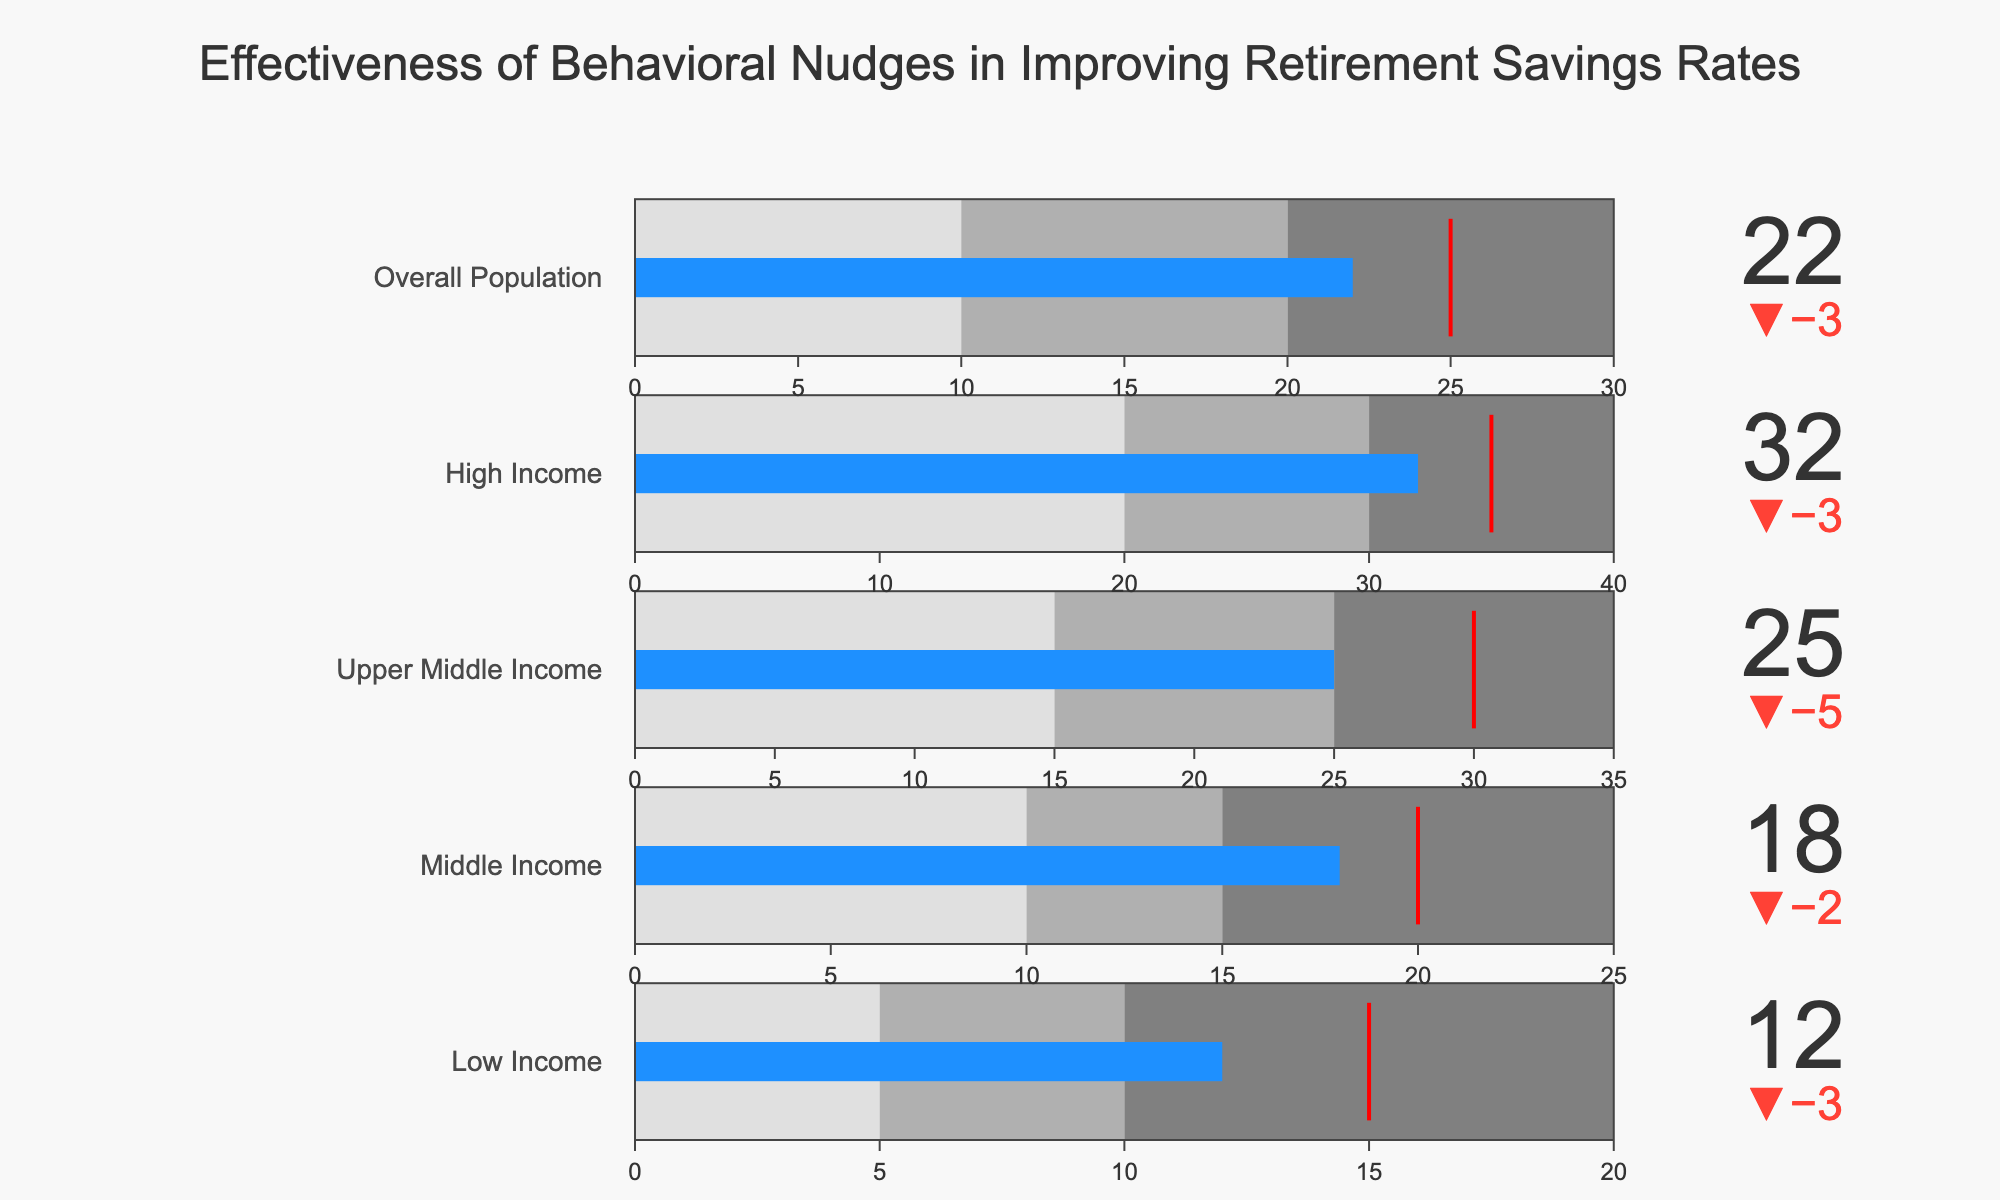What is the actual retirement savings rate for the "Middle Income" category? The "Middle Income" category has a bullet indicator, and the actual value is displayed as 18.
Answer: 18 How does the actual retirement savings rate compare to the target for the "Low Income" category? The "Low Income" category has an actual value of 12, and the target is 15, so the actual value is 3 less than the target.
Answer: 3 less Which income category has achieved the highest actual retirement savings rate? By looking at all the actual values, the "High Income" category has the highest actual rate at 32.
Answer: High Income Is the overall population's actual savings rate above or below the target? The actual value for the overall population is 22, and the target is 25, so it is below the target.
Answer: Below What is the range of the bullet gauge for the "Upper Middle Income" category? The gauge ranges from 0 to its high threshold which is 35 for the "Upper Middle Income" category.
Answer: 0 to 35 How much higher is the actual retirement savings rate for the "High Income" category compared to the "Low Income" category? Subtract the actual rate of "Low Income" (12) from "High Income" (32): 32 - 12 = 20.
Answer: 20 What is the difference between the target and actual savings rates for the "Overall Population"? The target is 25 and the actual is 22, so the difference is 25 - 22 = 3.
Answer: 3 Which income category has the smallest gap between the actual and target savings rates? By examining the deltas for each category, the "Middle Income" category has the smallest gap at 2.
Answer: Middle Income Did any of the categories exceed their high threshold value? None of the actual values exceed their respective high thresholds; all actual values are within their gauge ranges.
Answer: No What general pattern can be observed about the effectiveness of behavioral nudges across different income levels? Higher income categories tend to have higher actual savings rates, but they all still fall short of their target values, indicating that while nudges are effective, they are not completely bridging the gap to the targets.
Answer: Higher income, falls short 